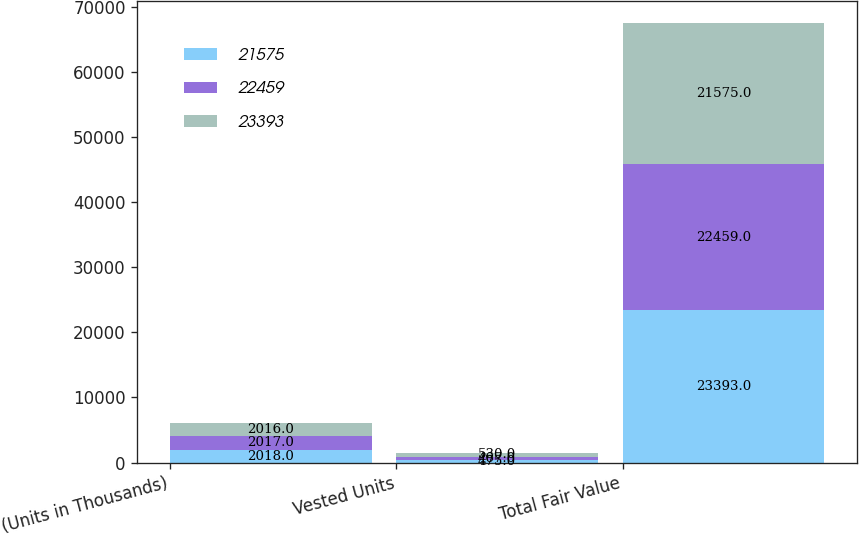Convert chart. <chart><loc_0><loc_0><loc_500><loc_500><stacked_bar_chart><ecel><fcel>(Units in Thousands)<fcel>Vested Units<fcel>Total Fair Value<nl><fcel>21575<fcel>2018<fcel>475<fcel>23393<nl><fcel>22459<fcel>2017<fcel>467<fcel>22459<nl><fcel>23393<fcel>2016<fcel>530<fcel>21575<nl></chart> 